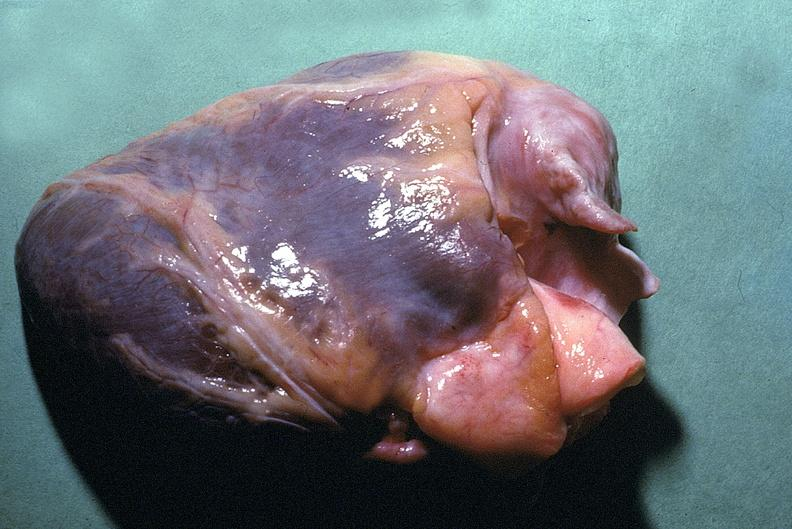does intraductal papillomatosis with apocrine metaplasia show normal cardiovascular?
Answer the question using a single word or phrase. No 